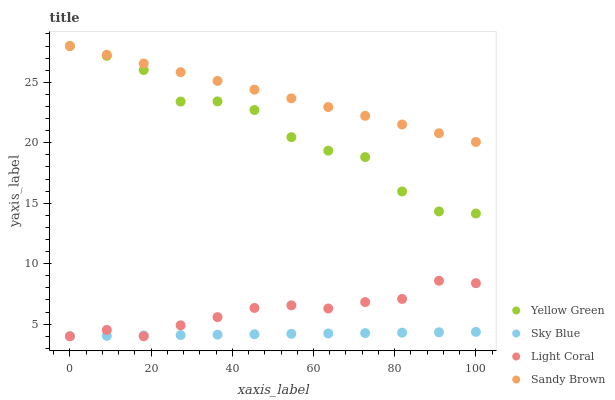Does Sky Blue have the minimum area under the curve?
Answer yes or no. Yes. Does Sandy Brown have the maximum area under the curve?
Answer yes or no. Yes. Does Sandy Brown have the minimum area under the curve?
Answer yes or no. No. Does Sky Blue have the maximum area under the curve?
Answer yes or no. No. Is Sky Blue the smoothest?
Answer yes or no. Yes. Is Yellow Green the roughest?
Answer yes or no. Yes. Is Sandy Brown the smoothest?
Answer yes or no. No. Is Sandy Brown the roughest?
Answer yes or no. No. Does Light Coral have the lowest value?
Answer yes or no. Yes. Does Sandy Brown have the lowest value?
Answer yes or no. No. Does Yellow Green have the highest value?
Answer yes or no. Yes. Does Sky Blue have the highest value?
Answer yes or no. No. Is Sky Blue less than Yellow Green?
Answer yes or no. Yes. Is Sandy Brown greater than Light Coral?
Answer yes or no. Yes. Does Light Coral intersect Sky Blue?
Answer yes or no. Yes. Is Light Coral less than Sky Blue?
Answer yes or no. No. Is Light Coral greater than Sky Blue?
Answer yes or no. No. Does Sky Blue intersect Yellow Green?
Answer yes or no. No. 